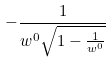<formula> <loc_0><loc_0><loc_500><loc_500>- \frac { 1 } { w ^ { 0 } \sqrt { 1 - \frac { 1 } { w ^ { 0 } } } }</formula> 